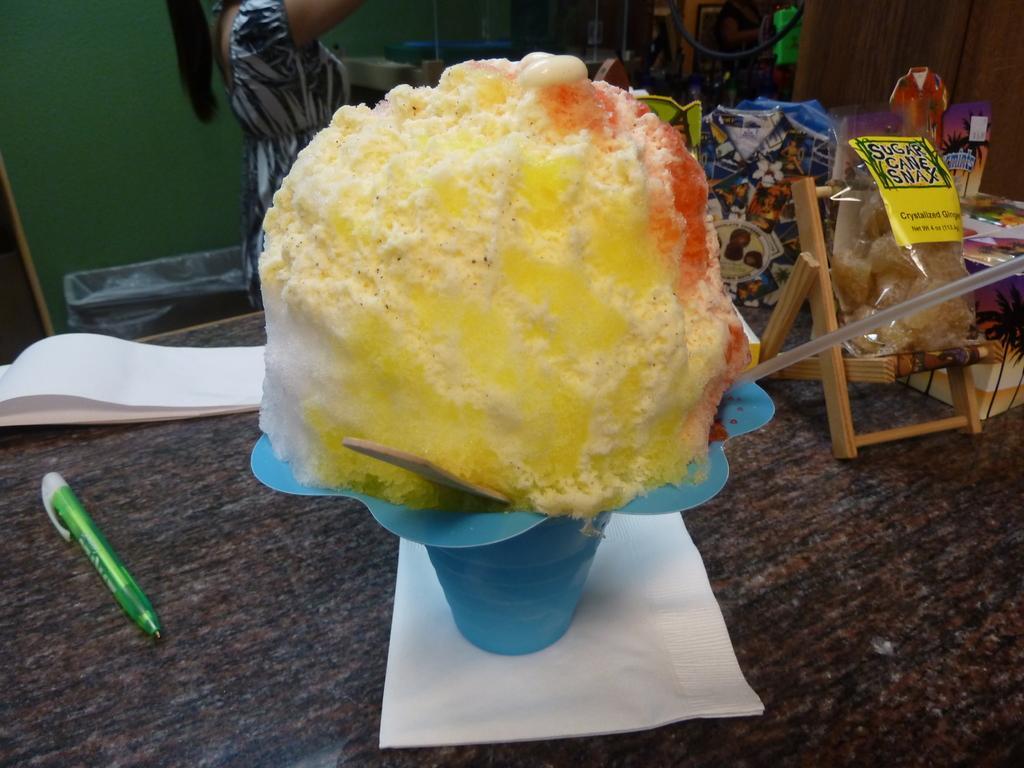Describe this image in one or two sentences. This picture seems to be clicked inside the room and we can see a person wearing a dress and standing and we can see a food item seems to be the ice cream is placed on the top of table and we can see the papers, pen, some food items, wooden object and some other objects are placed on the top of the table. In the background we can see the wall and many other objects. 